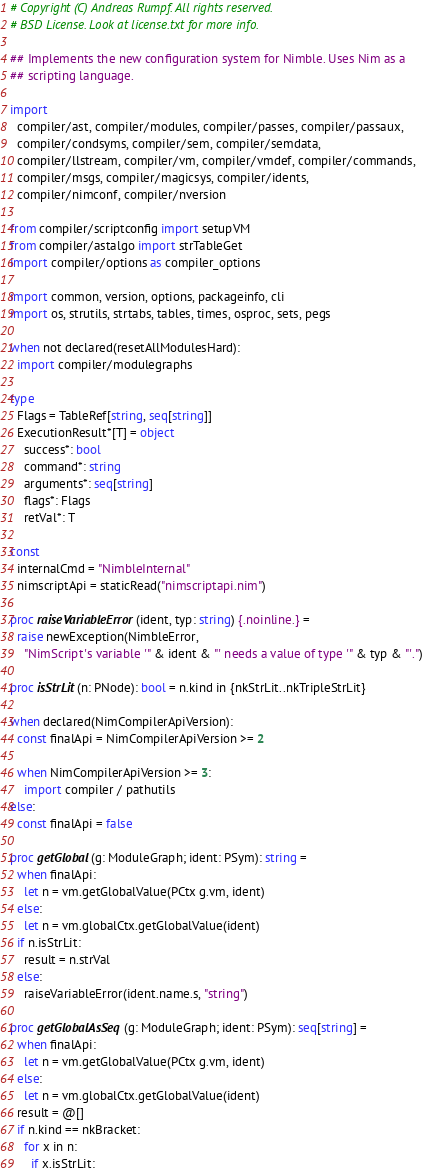<code> <loc_0><loc_0><loc_500><loc_500><_Nim_># Copyright (C) Andreas Rumpf. All rights reserved.
# BSD License. Look at license.txt for more info.

## Implements the new configuration system for Nimble. Uses Nim as a
## scripting language.

import
  compiler/ast, compiler/modules, compiler/passes, compiler/passaux,
  compiler/condsyms, compiler/sem, compiler/semdata,
  compiler/llstream, compiler/vm, compiler/vmdef, compiler/commands,
  compiler/msgs, compiler/magicsys, compiler/idents,
  compiler/nimconf, compiler/nversion

from compiler/scriptconfig import setupVM
from compiler/astalgo import strTableGet
import compiler/options as compiler_options

import common, version, options, packageinfo, cli
import os, strutils, strtabs, tables, times, osproc, sets, pegs

when not declared(resetAllModulesHard):
  import compiler/modulegraphs

type
  Flags = TableRef[string, seq[string]]
  ExecutionResult*[T] = object
    success*: bool
    command*: string
    arguments*: seq[string]
    flags*: Flags
    retVal*: T

const
  internalCmd = "NimbleInternal"
  nimscriptApi = staticRead("nimscriptapi.nim")

proc raiseVariableError(ident, typ: string) {.noinline.} =
  raise newException(NimbleError,
    "NimScript's variable '" & ident & "' needs a value of type '" & typ & "'.")

proc isStrLit(n: PNode): bool = n.kind in {nkStrLit..nkTripleStrLit}

when declared(NimCompilerApiVersion):
  const finalApi = NimCompilerApiVersion >= 2

  when NimCompilerApiVersion >= 3:
    import compiler / pathutils
else:
  const finalApi = false

proc getGlobal(g: ModuleGraph; ident: PSym): string =
  when finalApi:
    let n = vm.getGlobalValue(PCtx g.vm, ident)
  else:
    let n = vm.globalCtx.getGlobalValue(ident)
  if n.isStrLit:
    result = n.strVal
  else:
    raiseVariableError(ident.name.s, "string")

proc getGlobalAsSeq(g: ModuleGraph; ident: PSym): seq[string] =
  when finalApi:
    let n = vm.getGlobalValue(PCtx g.vm, ident)
  else:
    let n = vm.globalCtx.getGlobalValue(ident)
  result = @[]
  if n.kind == nkBracket:
    for x in n:
      if x.isStrLit:</code> 